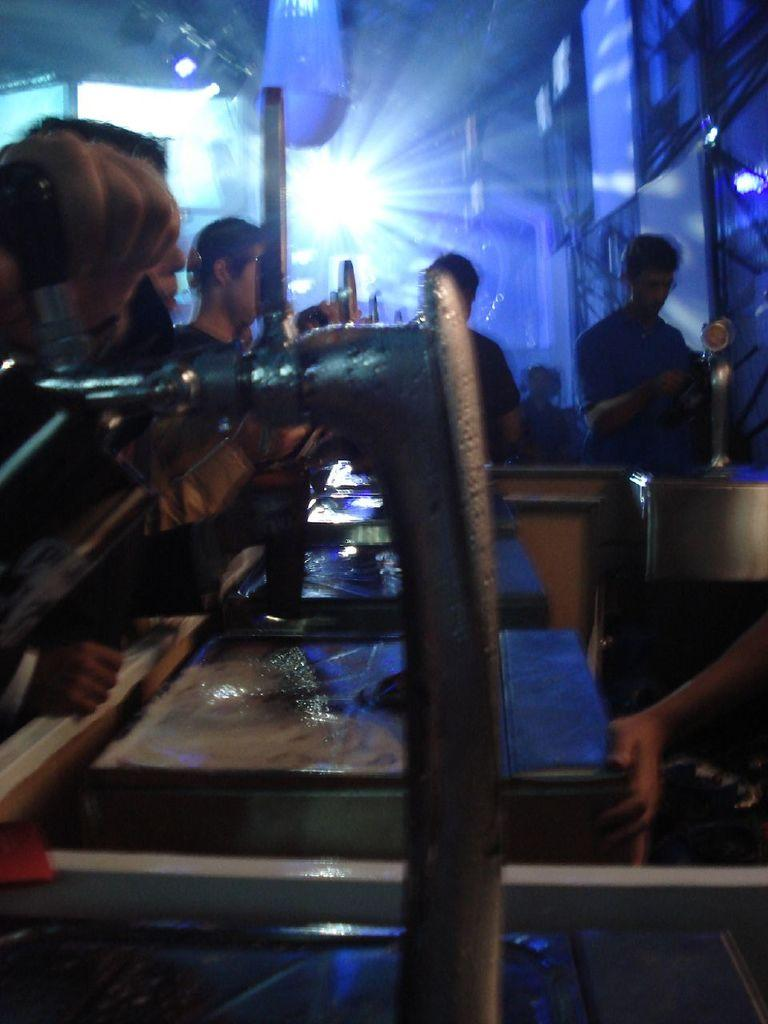How many people are in the image? There are people in the image, but the exact number is not specified. What are the people doing in the image? The people are standing in the image. What can be seen in the background of the image? There are blue lights in the background of the image. What type of drug is being sold by the people in the image? There is no indication in the image that the people are selling or using any drugs, so it cannot be determined from the picture. 